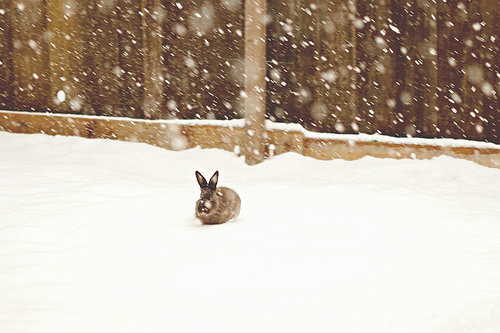<image>
Is there a rabbit above the snow? No. The rabbit is not positioned above the snow. The vertical arrangement shows a different relationship. 